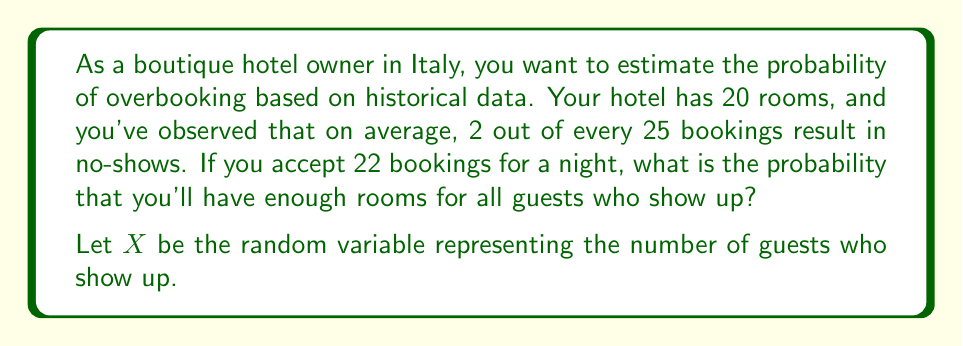Solve this math problem. To solve this problem, we'll follow these steps:

1) First, we need to identify the probability distribution that fits this scenario. Since we have a fixed number of trials (22 bookings) and each trial has two possible outcomes (show up or no-show), this follows a binomial distribution.

2) The probability of a guest showing up (p) is:
   $p = 1 - \frac{2}{25} = \frac{23}{25} = 0.92$

3) We want to find $P(X \leq 20)$, as this represents the probability of having enough rooms.

4) For a binomial distribution:
   $X \sim B(n,p)$ where $n = 22$ and $p = 0.92$

5) We can calculate this using the cumulative binomial probability function:

   $$P(X \leq 20) = \sum_{k=0}^{20} \binom{22}{k} (0.92)^k (0.08)^{22-k}$$

6) This calculation is complex to do by hand, so we would typically use statistical software or a calculator with a binomial cumulative distribution function.

7) Using such a tool, we find:

   $P(X \leq 20) \approx 0.2434$

Therefore, the probability of having enough rooms for all guests who show up is approximately 0.2434 or 24.34%.
Answer: 0.2434 